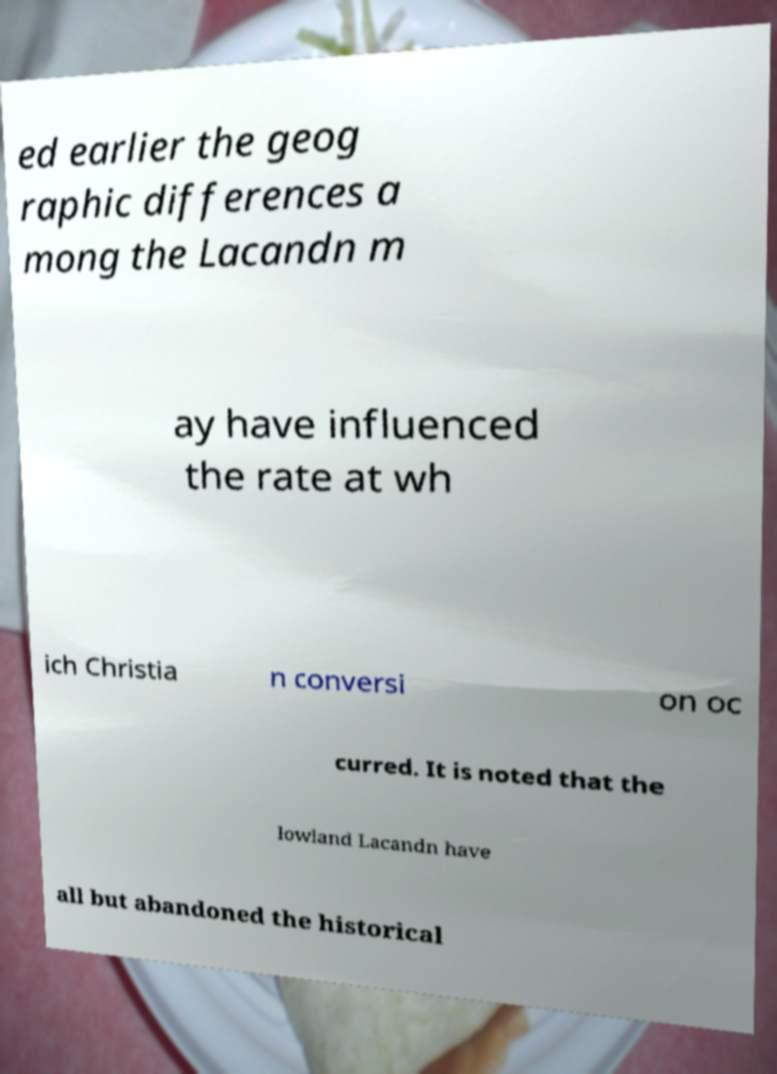Can you accurately transcribe the text from the provided image for me? ed earlier the geog raphic differences a mong the Lacandn m ay have influenced the rate at wh ich Christia n conversi on oc curred. It is noted that the lowland Lacandn have all but abandoned the historical 